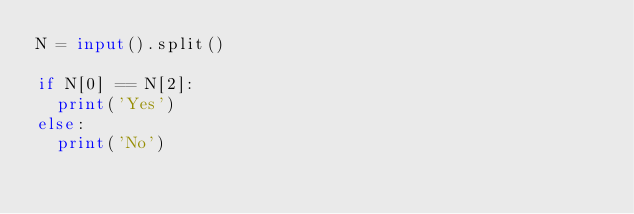<code> <loc_0><loc_0><loc_500><loc_500><_Python_>N = input().split()

if N[0] == N[2]:
  print('Yes')
else:
  print('No')</code> 